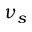<formula> <loc_0><loc_0><loc_500><loc_500>\nu _ { s }</formula> 